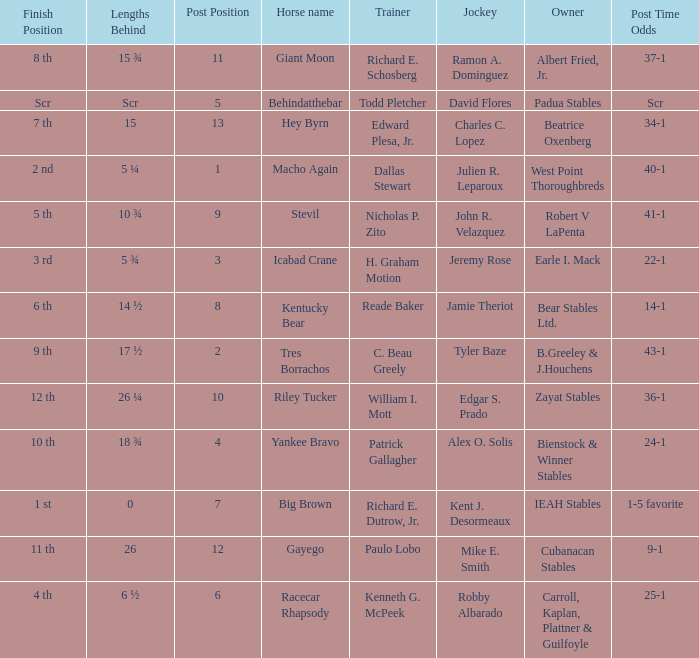Who was the jockey that had post time odds of 34-1? Charles C. Lopez. 